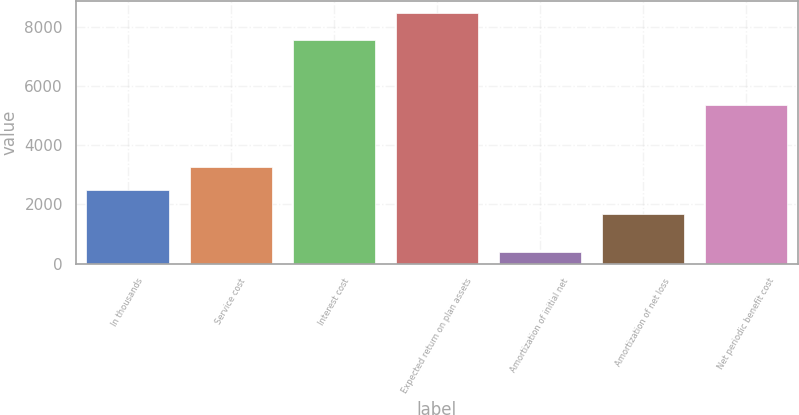Convert chart. <chart><loc_0><loc_0><loc_500><loc_500><bar_chart><fcel>In thousands<fcel>Service cost<fcel>Interest cost<fcel>Expected return on plan assets<fcel>Amortization of initial net<fcel>Amortization of net loss<fcel>Net periodic benefit cost<nl><fcel>2474.7<fcel>3284.4<fcel>7575<fcel>8477<fcel>380<fcel>1665<fcel>5371<nl></chart> 